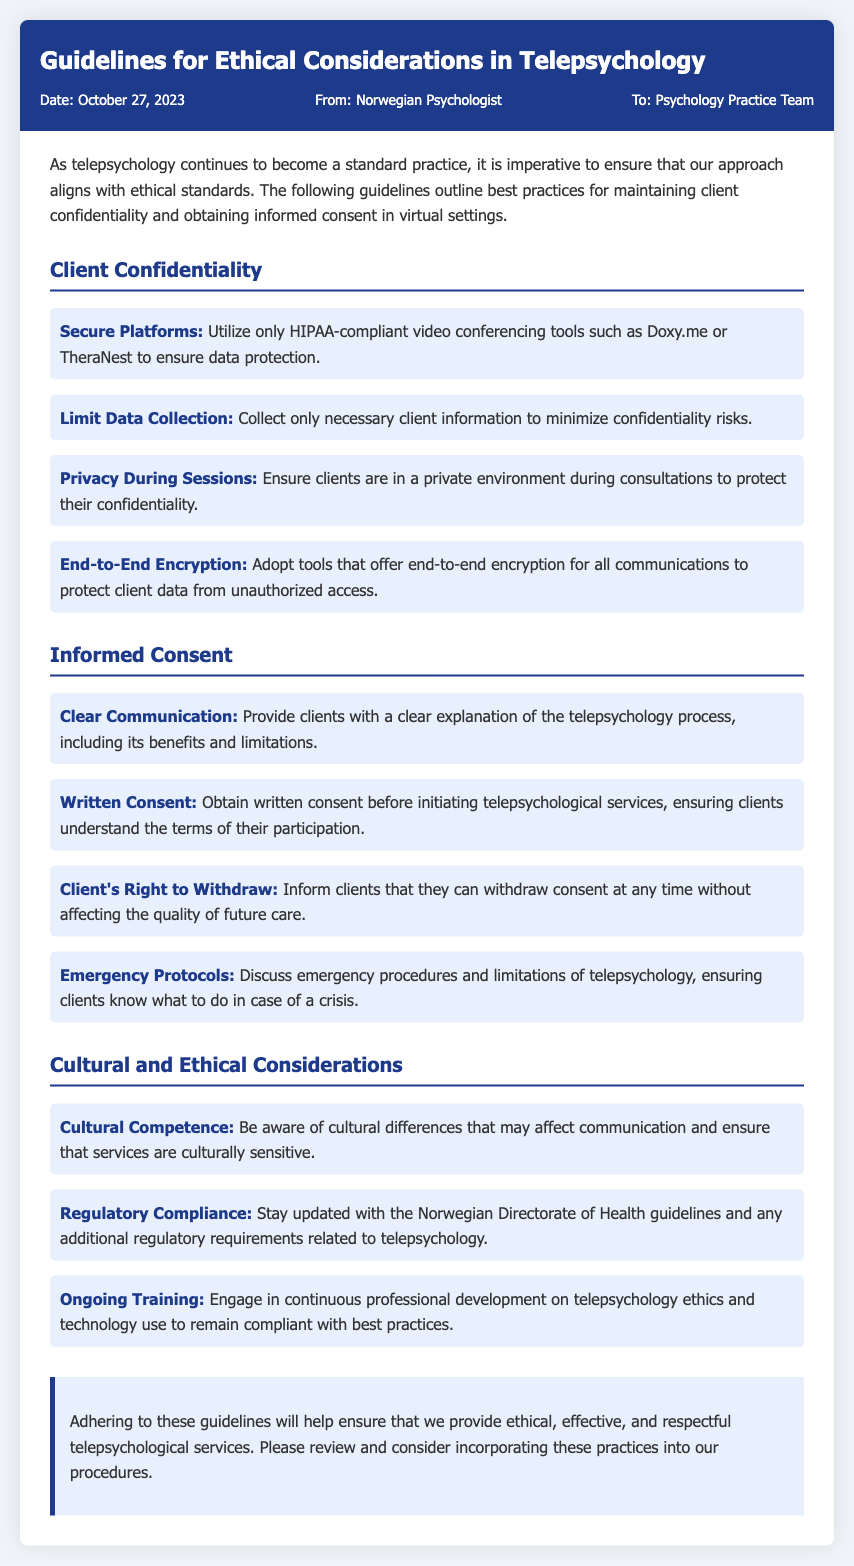what is the date of the memo? The date of the memo is provided in the header section, which states October 27, 2023.
Answer: October 27, 2023 who is the memo addressed to? The recipient of the memo is indicated in the header, which states the memo is addressed to the Psychology Practice Team.
Answer: Psychology Practice Team what is emphasized under Client Confidentiality? The document lists several key points under Client Confidentiality, such as "Secure Platforms," "Limit Data Collection," among others.
Answer: Secure Platforms how can clients withdraw from telepsychology services? The memo specifies that clients can withdraw consent at any time without affecting future care quality.
Answer: Without affecting the quality of future care what is the role of cultural competence in telepsychology? The memo outlines that cultural competence is important for ensuring services are culturally sensitive, which is mentioned in the Cultural and Ethical Considerations section.
Answer: To ensure services are culturally sensitive what should clients be informed about regarding emergency protocols? The document indicates that clients should discuss emergency procedures and limitations of telepsychology.
Answer: Emergency procedures and limitations how is informed consent obtained in the telepsychology process? The guidelines specify that written consent must be obtained before initiating telepsychological services.
Answer: Written consent what type of platforms should be used for telepsychology? The document advises utilizing HIPAA-compliant video conferencing tools to ensure data protection.
Answer: HIPAA-compliant video conferencing tools 